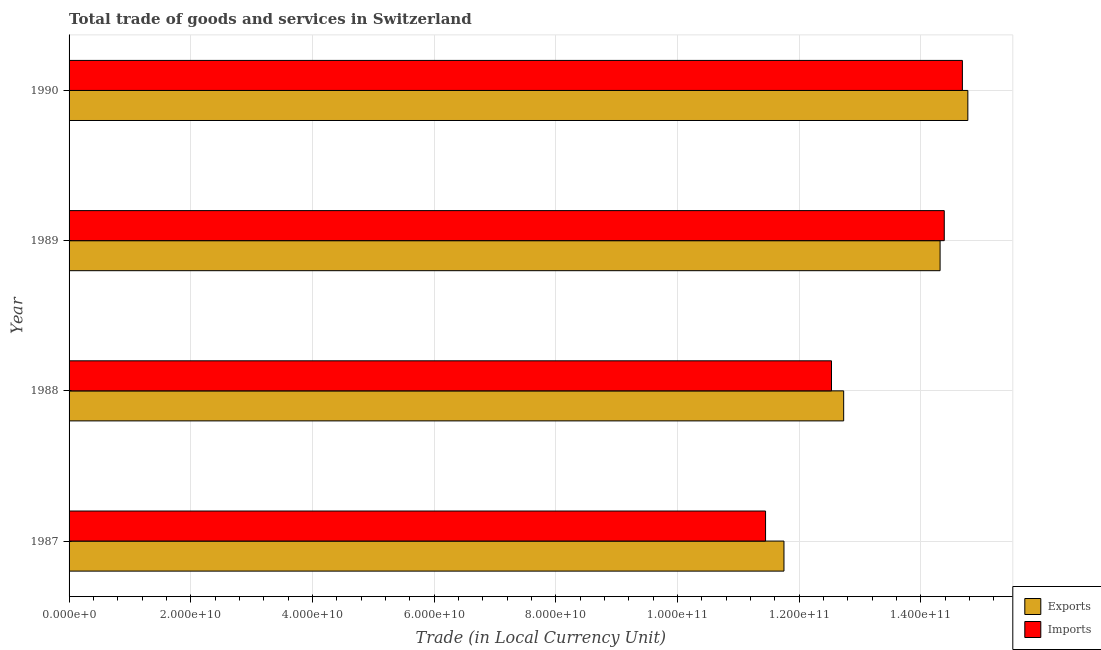How many different coloured bars are there?
Offer a terse response. 2. How many groups of bars are there?
Provide a succinct answer. 4. Are the number of bars per tick equal to the number of legend labels?
Provide a succinct answer. Yes. Are the number of bars on each tick of the Y-axis equal?
Provide a short and direct response. Yes. How many bars are there on the 3rd tick from the top?
Ensure brevity in your answer.  2. How many bars are there on the 4th tick from the bottom?
Keep it short and to the point. 2. What is the export of goods and services in 1990?
Make the answer very short. 1.48e+11. Across all years, what is the maximum imports of goods and services?
Provide a succinct answer. 1.47e+11. Across all years, what is the minimum imports of goods and services?
Provide a short and direct response. 1.14e+11. In which year was the imports of goods and services maximum?
Your response must be concise. 1990. What is the total export of goods and services in the graph?
Provide a short and direct response. 5.36e+11. What is the difference between the export of goods and services in 1989 and that in 1990?
Keep it short and to the point. -4.56e+09. What is the difference between the export of goods and services in 1989 and the imports of goods and services in 1990?
Offer a very short reply. -3.67e+09. What is the average imports of goods and services per year?
Your answer should be compact. 1.33e+11. In the year 1990, what is the difference between the imports of goods and services and export of goods and services?
Ensure brevity in your answer.  -8.96e+08. In how many years, is the export of goods and services greater than 76000000000 LCU?
Make the answer very short. 4. What is the ratio of the export of goods and services in 1988 to that in 1990?
Offer a very short reply. 0.86. Is the export of goods and services in 1988 less than that in 1989?
Your response must be concise. Yes. What is the difference between the highest and the second highest export of goods and services?
Provide a short and direct response. 4.56e+09. What is the difference between the highest and the lowest export of goods and services?
Make the answer very short. 3.02e+1. What does the 2nd bar from the top in 1988 represents?
Make the answer very short. Exports. What does the 1st bar from the bottom in 1989 represents?
Offer a very short reply. Exports. How many bars are there?
Your answer should be compact. 8. Where does the legend appear in the graph?
Your answer should be very brief. Bottom right. How are the legend labels stacked?
Offer a very short reply. Vertical. What is the title of the graph?
Offer a terse response. Total trade of goods and services in Switzerland. What is the label or title of the X-axis?
Provide a succinct answer. Trade (in Local Currency Unit). What is the Trade (in Local Currency Unit) in Exports in 1987?
Ensure brevity in your answer.  1.18e+11. What is the Trade (in Local Currency Unit) in Imports in 1987?
Your answer should be very brief. 1.14e+11. What is the Trade (in Local Currency Unit) of Exports in 1988?
Offer a very short reply. 1.27e+11. What is the Trade (in Local Currency Unit) of Imports in 1988?
Offer a terse response. 1.25e+11. What is the Trade (in Local Currency Unit) of Exports in 1989?
Give a very brief answer. 1.43e+11. What is the Trade (in Local Currency Unit) of Imports in 1989?
Offer a terse response. 1.44e+11. What is the Trade (in Local Currency Unit) in Exports in 1990?
Provide a succinct answer. 1.48e+11. What is the Trade (in Local Currency Unit) in Imports in 1990?
Give a very brief answer. 1.47e+11. Across all years, what is the maximum Trade (in Local Currency Unit) of Exports?
Offer a very short reply. 1.48e+11. Across all years, what is the maximum Trade (in Local Currency Unit) in Imports?
Your answer should be compact. 1.47e+11. Across all years, what is the minimum Trade (in Local Currency Unit) in Exports?
Provide a succinct answer. 1.18e+11. Across all years, what is the minimum Trade (in Local Currency Unit) in Imports?
Make the answer very short. 1.14e+11. What is the total Trade (in Local Currency Unit) in Exports in the graph?
Provide a succinct answer. 5.36e+11. What is the total Trade (in Local Currency Unit) of Imports in the graph?
Keep it short and to the point. 5.30e+11. What is the difference between the Trade (in Local Currency Unit) in Exports in 1987 and that in 1988?
Your answer should be compact. -9.81e+09. What is the difference between the Trade (in Local Currency Unit) of Imports in 1987 and that in 1988?
Your answer should be compact. -1.08e+1. What is the difference between the Trade (in Local Currency Unit) in Exports in 1987 and that in 1989?
Provide a succinct answer. -2.57e+1. What is the difference between the Trade (in Local Currency Unit) of Imports in 1987 and that in 1989?
Your answer should be compact. -2.94e+1. What is the difference between the Trade (in Local Currency Unit) of Exports in 1987 and that in 1990?
Provide a succinct answer. -3.02e+1. What is the difference between the Trade (in Local Currency Unit) of Imports in 1987 and that in 1990?
Give a very brief answer. -3.24e+1. What is the difference between the Trade (in Local Currency Unit) in Exports in 1988 and that in 1989?
Give a very brief answer. -1.58e+1. What is the difference between the Trade (in Local Currency Unit) of Imports in 1988 and that in 1989?
Offer a terse response. -1.85e+1. What is the difference between the Trade (in Local Currency Unit) of Exports in 1988 and that in 1990?
Your answer should be compact. -2.04e+1. What is the difference between the Trade (in Local Currency Unit) of Imports in 1988 and that in 1990?
Ensure brevity in your answer.  -2.15e+1. What is the difference between the Trade (in Local Currency Unit) of Exports in 1989 and that in 1990?
Provide a succinct answer. -4.56e+09. What is the difference between the Trade (in Local Currency Unit) of Imports in 1989 and that in 1990?
Offer a very short reply. -2.98e+09. What is the difference between the Trade (in Local Currency Unit) of Exports in 1987 and the Trade (in Local Currency Unit) of Imports in 1988?
Ensure brevity in your answer.  -7.81e+09. What is the difference between the Trade (in Local Currency Unit) of Exports in 1987 and the Trade (in Local Currency Unit) of Imports in 1989?
Offer a very short reply. -2.63e+1. What is the difference between the Trade (in Local Currency Unit) of Exports in 1987 and the Trade (in Local Currency Unit) of Imports in 1990?
Give a very brief answer. -2.93e+1. What is the difference between the Trade (in Local Currency Unit) of Exports in 1988 and the Trade (in Local Currency Unit) of Imports in 1989?
Offer a terse response. -1.65e+1. What is the difference between the Trade (in Local Currency Unit) of Exports in 1988 and the Trade (in Local Currency Unit) of Imports in 1990?
Offer a very short reply. -1.95e+1. What is the difference between the Trade (in Local Currency Unit) in Exports in 1989 and the Trade (in Local Currency Unit) in Imports in 1990?
Make the answer very short. -3.67e+09. What is the average Trade (in Local Currency Unit) in Exports per year?
Give a very brief answer. 1.34e+11. What is the average Trade (in Local Currency Unit) of Imports per year?
Your answer should be compact. 1.33e+11. In the year 1987, what is the difference between the Trade (in Local Currency Unit) in Exports and Trade (in Local Currency Unit) in Imports?
Offer a terse response. 3.02e+09. In the year 1988, what is the difference between the Trade (in Local Currency Unit) of Exports and Trade (in Local Currency Unit) of Imports?
Keep it short and to the point. 2.00e+09. In the year 1989, what is the difference between the Trade (in Local Currency Unit) in Exports and Trade (in Local Currency Unit) in Imports?
Ensure brevity in your answer.  -6.88e+08. In the year 1990, what is the difference between the Trade (in Local Currency Unit) of Exports and Trade (in Local Currency Unit) of Imports?
Keep it short and to the point. 8.96e+08. What is the ratio of the Trade (in Local Currency Unit) of Exports in 1987 to that in 1988?
Provide a short and direct response. 0.92. What is the ratio of the Trade (in Local Currency Unit) in Imports in 1987 to that in 1988?
Offer a very short reply. 0.91. What is the ratio of the Trade (in Local Currency Unit) in Exports in 1987 to that in 1989?
Your answer should be very brief. 0.82. What is the ratio of the Trade (in Local Currency Unit) of Imports in 1987 to that in 1989?
Keep it short and to the point. 0.8. What is the ratio of the Trade (in Local Currency Unit) in Exports in 1987 to that in 1990?
Your answer should be compact. 0.8. What is the ratio of the Trade (in Local Currency Unit) of Imports in 1987 to that in 1990?
Offer a very short reply. 0.78. What is the ratio of the Trade (in Local Currency Unit) of Exports in 1988 to that in 1989?
Ensure brevity in your answer.  0.89. What is the ratio of the Trade (in Local Currency Unit) of Imports in 1988 to that in 1989?
Make the answer very short. 0.87. What is the ratio of the Trade (in Local Currency Unit) in Exports in 1988 to that in 1990?
Keep it short and to the point. 0.86. What is the ratio of the Trade (in Local Currency Unit) of Imports in 1988 to that in 1990?
Offer a terse response. 0.85. What is the ratio of the Trade (in Local Currency Unit) in Exports in 1989 to that in 1990?
Provide a short and direct response. 0.97. What is the ratio of the Trade (in Local Currency Unit) in Imports in 1989 to that in 1990?
Keep it short and to the point. 0.98. What is the difference between the highest and the second highest Trade (in Local Currency Unit) in Exports?
Offer a very short reply. 4.56e+09. What is the difference between the highest and the second highest Trade (in Local Currency Unit) in Imports?
Your response must be concise. 2.98e+09. What is the difference between the highest and the lowest Trade (in Local Currency Unit) in Exports?
Your response must be concise. 3.02e+1. What is the difference between the highest and the lowest Trade (in Local Currency Unit) of Imports?
Ensure brevity in your answer.  3.24e+1. 